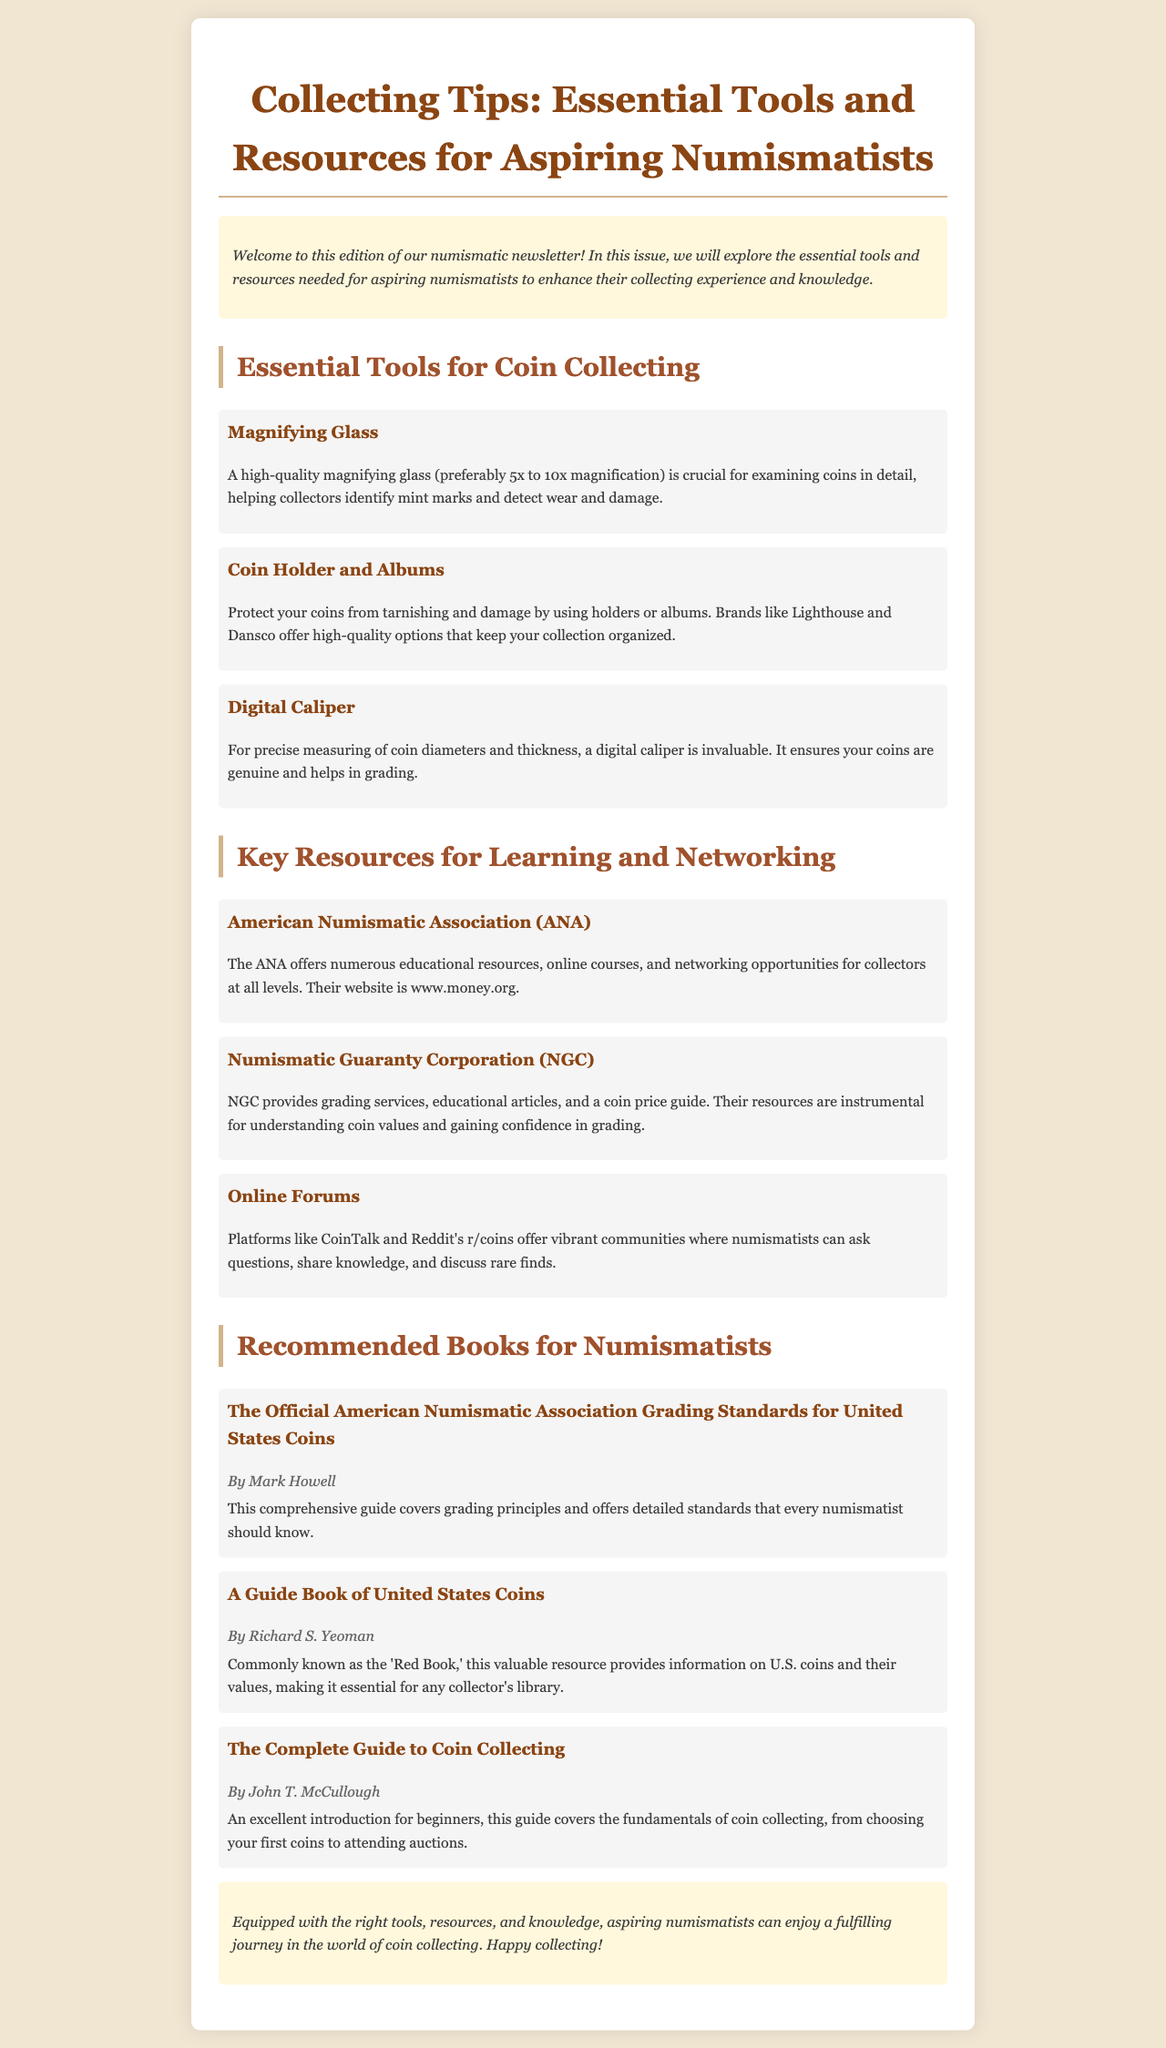What is the title of the newsletter? The title of the newsletter is found at the top and indicates the main topic covered in this edition.
Answer: Collecting Tips: Essential Tools and Resources for Aspiring Numismatists What is a recommended magnification for a magnifying glass? The document specifies the preferred range of magnification for a magnifying glass important for examining coins.
Answer: 5x to 10x Which organization offers online courses for numismatists? The named organization provides educational resources and courses for collectors at various levels within the document.
Answer: American Numismatic Association (ANA) What is a benefit of using coin holders? The document describes a protective feature of using holders or albums for coins, highlighting their protection function.
Answer: Protect your coins from tarnishing and damage Who is the author of the 'Red Book'? The document contains the name of the author associated with the well-known book on U.S. coins, commonly referred to as the 'Red Book'.
Answer: Richard S. Yeoman What type of caliper is considered invaluable for coin measurement? The document specifically highlights a measuring tool that is crucial for determining the dimensions of coins for numismatists.
Answer: Digital Caliper Which platform is mentioned as a community for numismatists? The document lists specific online platforms where coin collectors can engage in discussions and share knowledge about numismatics.
Answer: CoinTalk What does the guide by Mark Howell cover? The document outlines the focus of the book authored by Mark Howell related to grading principles for coins.
Answer: Grading principles and detailed standards 